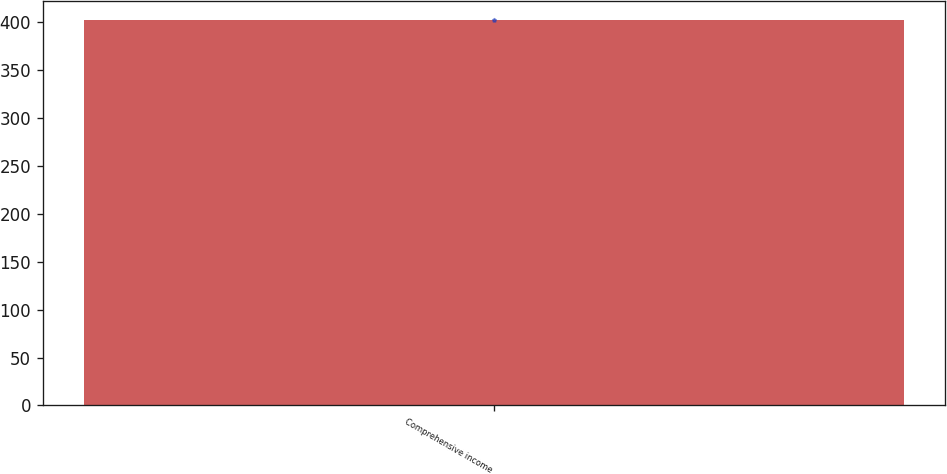Convert chart to OTSL. <chart><loc_0><loc_0><loc_500><loc_500><bar_chart><fcel>Comprehensive income<nl><fcel>402.1<nl></chart> 